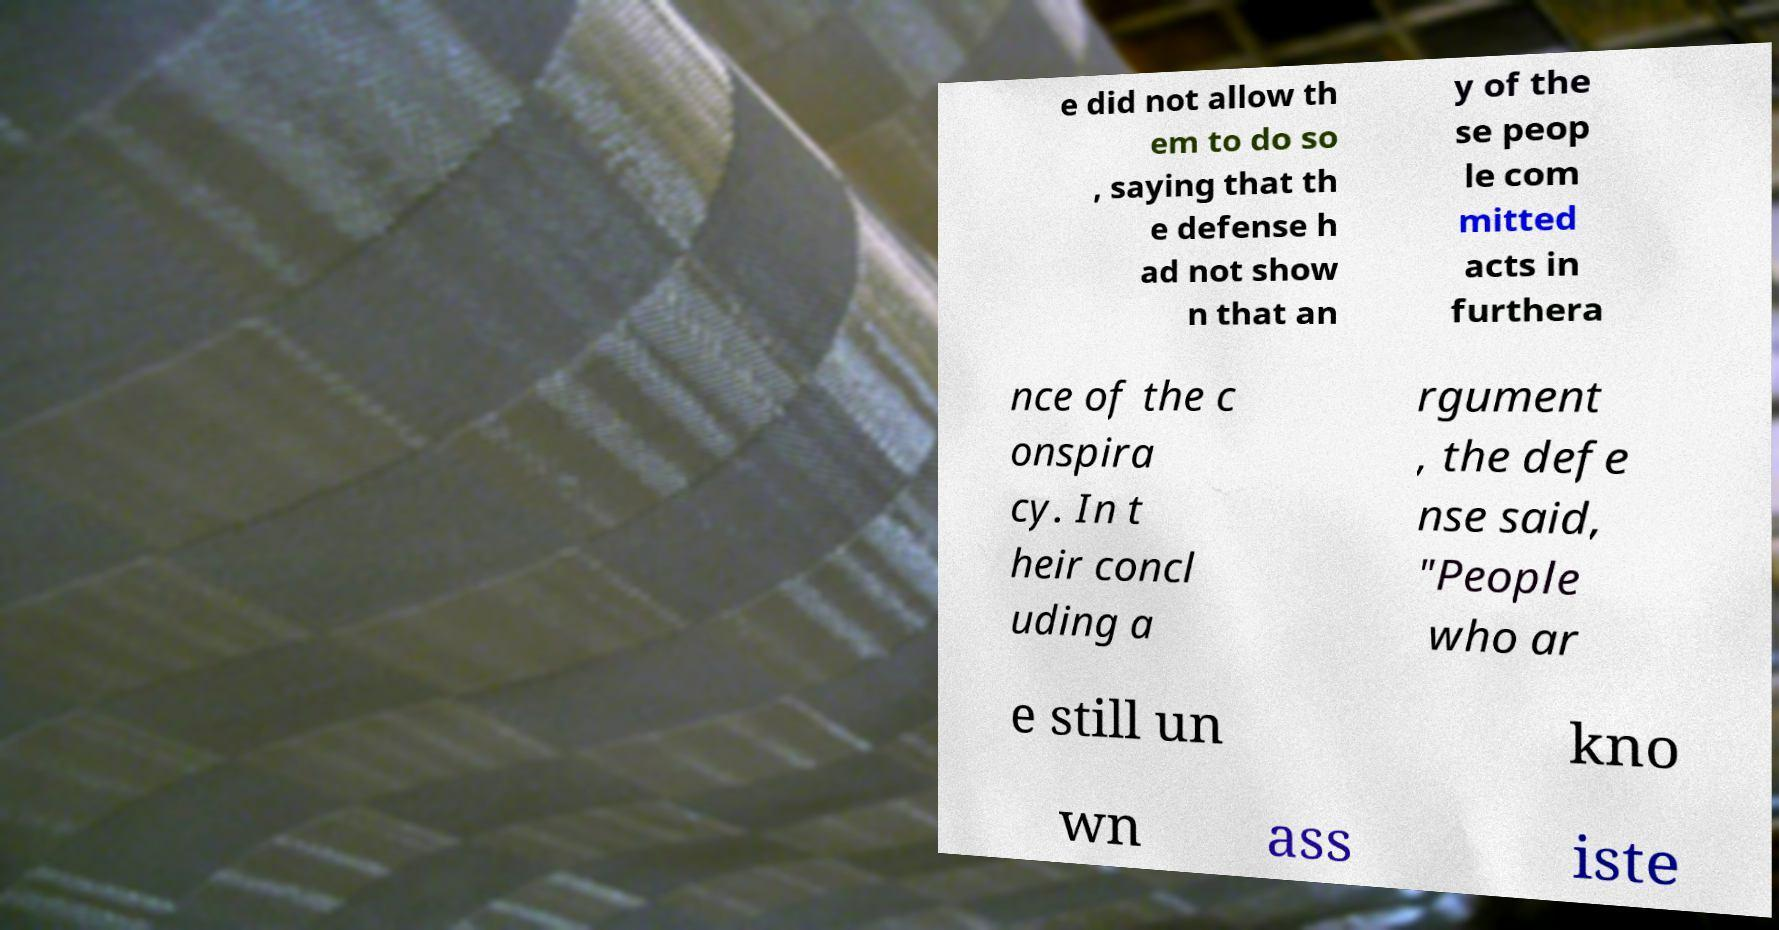There's text embedded in this image that I need extracted. Can you transcribe it verbatim? e did not allow th em to do so , saying that th e defense h ad not show n that an y of the se peop le com mitted acts in furthera nce of the c onspira cy. In t heir concl uding a rgument , the defe nse said, "People who ar e still un kno wn ass iste 